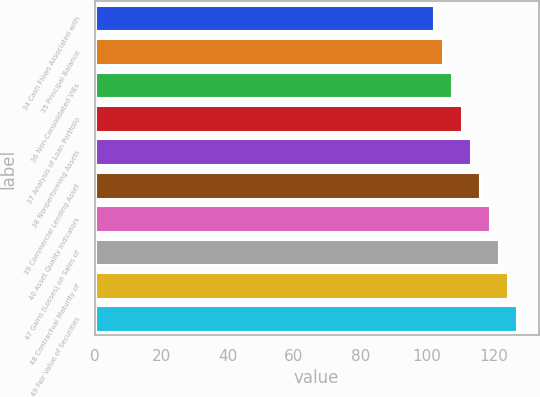Convert chart to OTSL. <chart><loc_0><loc_0><loc_500><loc_500><bar_chart><fcel>34 Cash Flows Associated with<fcel>35 Principal Balance<fcel>36 Non-Consolidated VIEs<fcel>37 Analysis of Loan Portfolio<fcel>38 Nonperforming Assets<fcel>39 Commercial Lending Asset<fcel>40 Asset Quality Indicators<fcel>47 Gains (Losses) on Sales of<fcel>48 Contractual Maturity of<fcel>49 Fair Value of Securities<nl><fcel>102<fcel>104.8<fcel>107.6<fcel>110.4<fcel>113.2<fcel>116<fcel>118.8<fcel>121.6<fcel>124.4<fcel>127.2<nl></chart> 